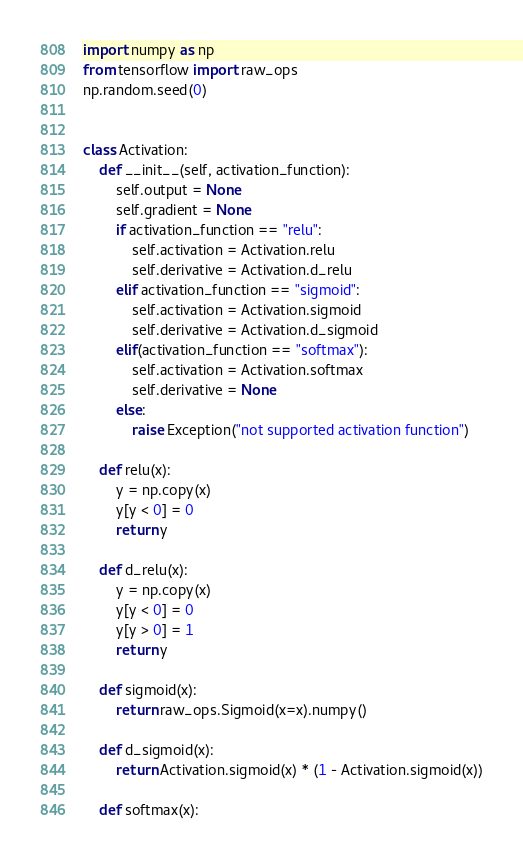Convert code to text. <code><loc_0><loc_0><loc_500><loc_500><_Python_>import numpy as np
from tensorflow import raw_ops
np.random.seed(0)


class Activation:
    def __init__(self, activation_function):
        self.output = None
        self.gradient = None
        if activation_function == "relu":
            self.activation = Activation.relu
            self.derivative = Activation.d_relu
        elif activation_function == "sigmoid":
            self.activation = Activation.sigmoid
            self.derivative = Activation.d_sigmoid
        elif(activation_function == "softmax"):
            self.activation = Activation.softmax
            self.derivative = None
        else:
            raise Exception("not supported activation function")

    def relu(x):
        y = np.copy(x)
        y[y < 0] = 0
        return y

    def d_relu(x):
        y = np.copy(x)
        y[y < 0] = 0
        y[y > 0] = 1
        return y

    def sigmoid(x):
        return raw_ops.Sigmoid(x=x).numpy()

    def d_sigmoid(x):
        return Activation.sigmoid(x) * (1 - Activation.sigmoid(x))

    def softmax(x):</code> 